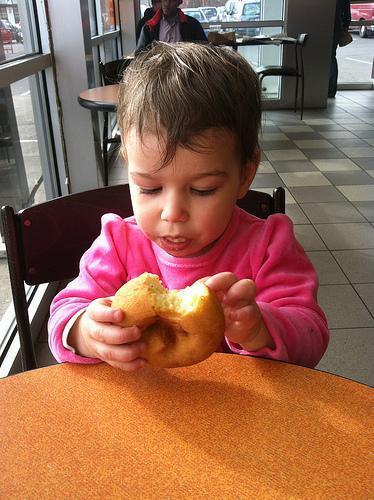How many bites appear to have been taken from the donut?
Give a very brief answer. 1. 